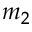<formula> <loc_0><loc_0><loc_500><loc_500>m _ { 2 }</formula> 